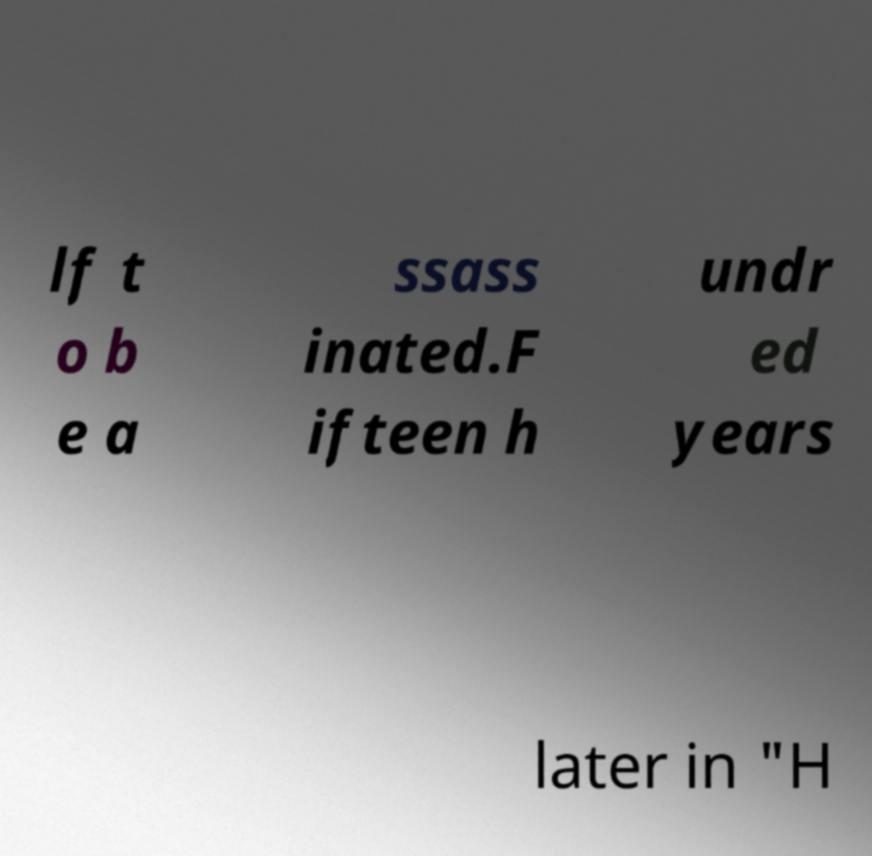Please identify and transcribe the text found in this image. lf t o b e a ssass inated.F ifteen h undr ed years later in "H 